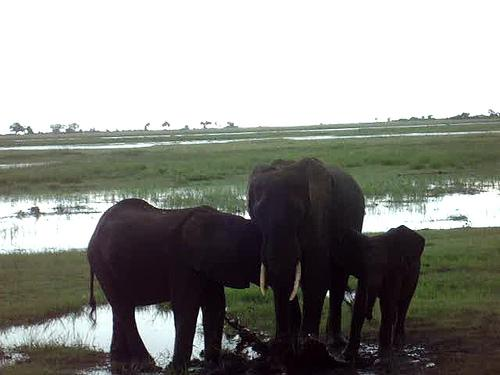Question: when was the picture taken?
Choices:
A. In the morning.
B. In midday.
C. In the afternoon.
D. At dusk.
Answer with the letter. Answer: C Question: what color are the elephants?
Choices:
A. Brown.
B. Gray.
C. Black.
D. White.
Answer with the letter. Answer: B Question: how many elephants are in the picture?
Choices:
A. 2.
B. 1.
C. 3.
D. 4.
Answer with the letter. Answer: C 